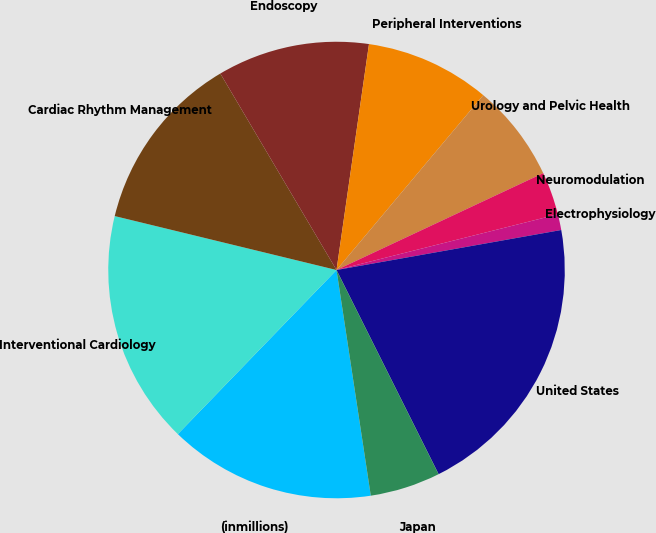Convert chart to OTSL. <chart><loc_0><loc_0><loc_500><loc_500><pie_chart><fcel>(inmillions)<fcel>Interventional Cardiology<fcel>Cardiac Rhythm Management<fcel>Endoscopy<fcel>Peripheral Interventions<fcel>Urology and Pelvic Health<fcel>Neuromodulation<fcel>Electrophysiology<fcel>United States<fcel>Japan<nl><fcel>14.63%<fcel>16.56%<fcel>12.7%<fcel>10.77%<fcel>8.84%<fcel>6.91%<fcel>3.05%<fcel>1.12%<fcel>20.42%<fcel>4.98%<nl></chart> 